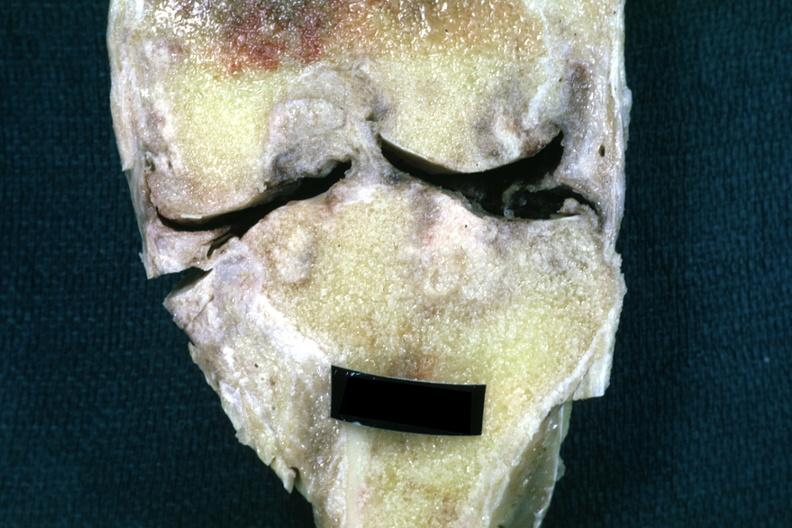does this image show fixed tissue frontal section of joint with obvious cartilage loss and subsynovial fibrosis?
Answer the question using a single word or phrase. Yes 